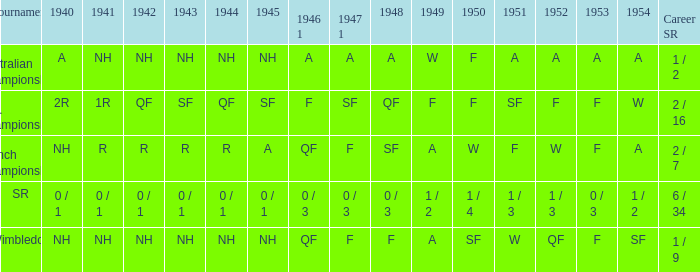What is the 1944 result for the U.S. Championships? QF. 